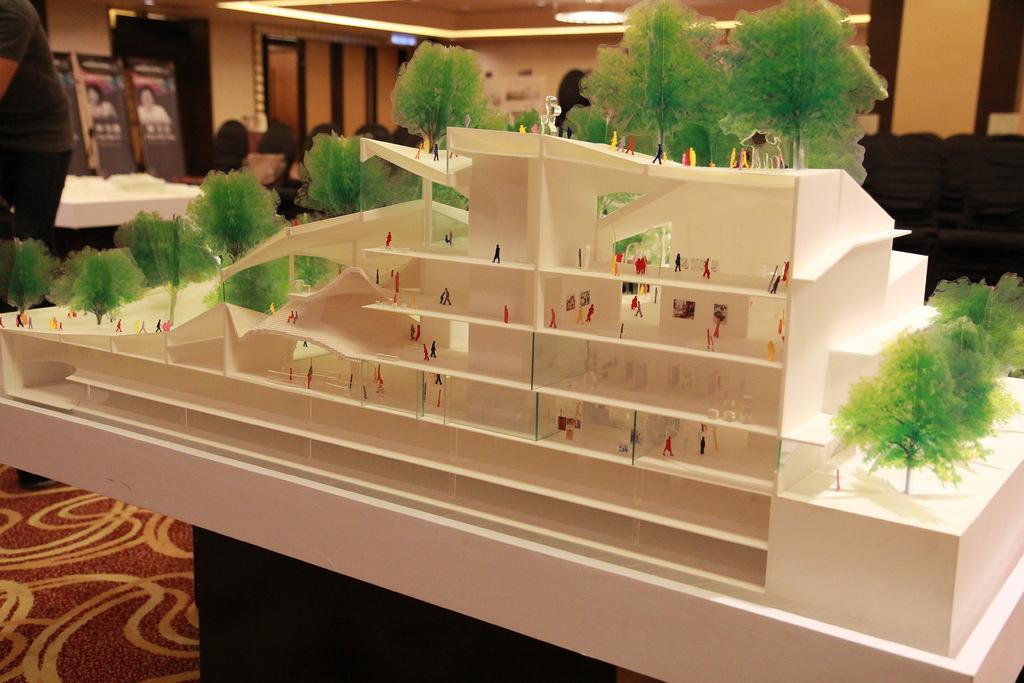Describe this image in one or two sentences. In this picture we can see few people and a miniature, in the background we can find few lights, tables and frames. 